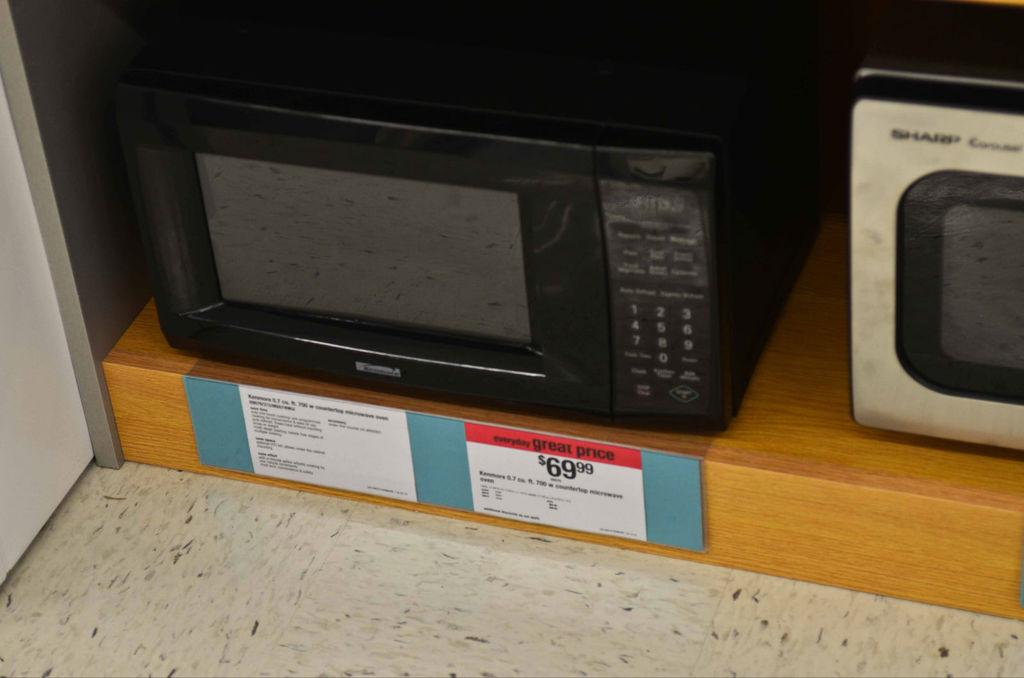<image>
Relay a brief, clear account of the picture shown. A black microwave oven that costs % 69.99 